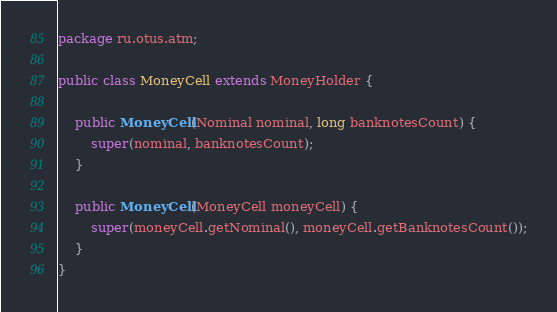<code> <loc_0><loc_0><loc_500><loc_500><_Java_>package ru.otus.atm;

public class MoneyCell extends MoneyHolder {

    public MoneyCell(Nominal nominal, long banknotesCount) {
        super(nominal, banknotesCount);
    }

    public MoneyCell(MoneyCell moneyCell) {
        super(moneyCell.getNominal(), moneyCell.getBanknotesCount());
    }
}
</code> 